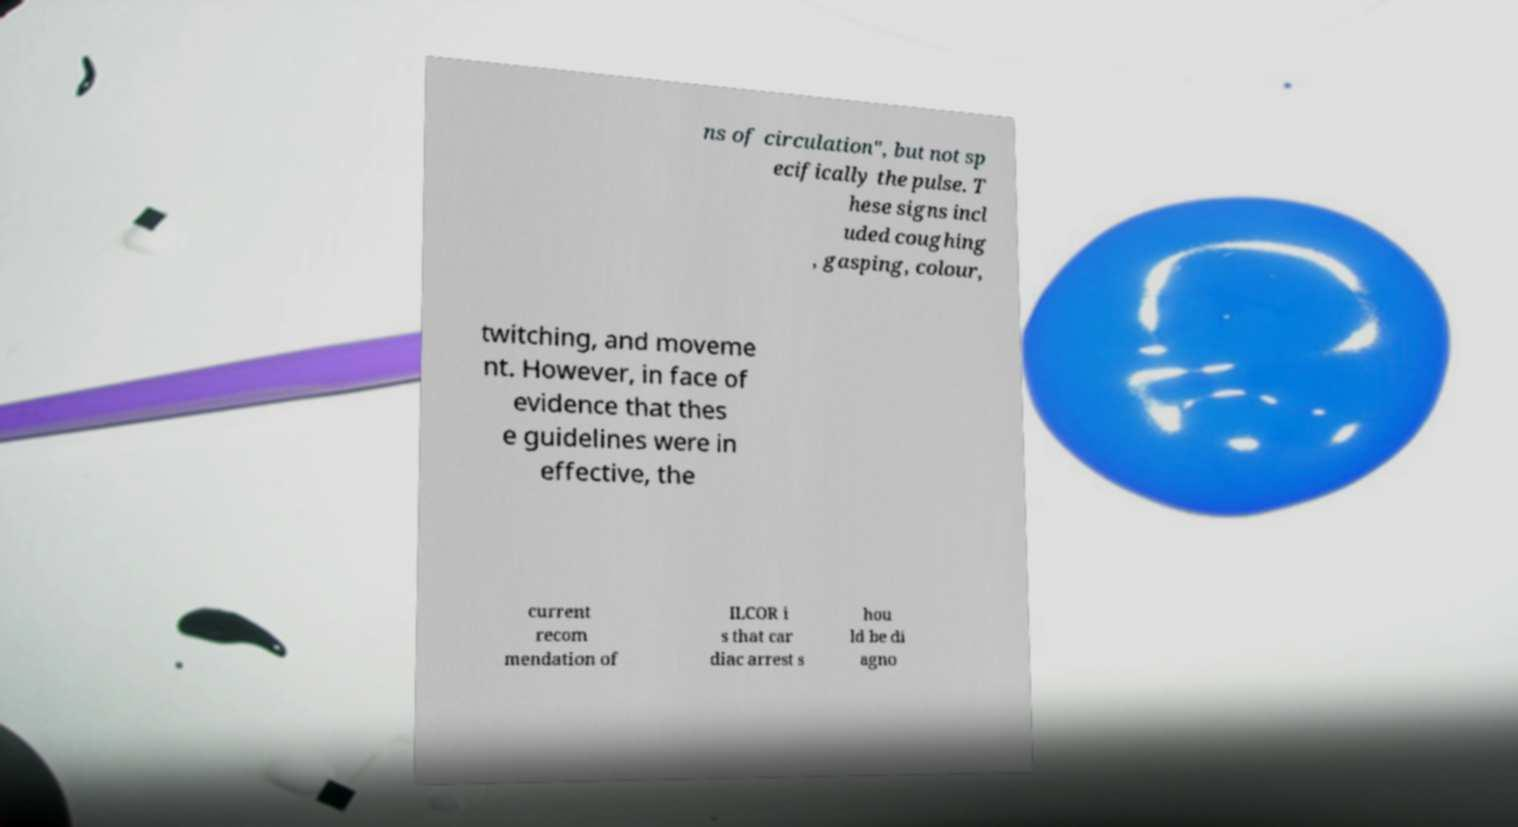Can you accurately transcribe the text from the provided image for me? ns of circulation", but not sp ecifically the pulse. T hese signs incl uded coughing , gasping, colour, twitching, and moveme nt. However, in face of evidence that thes e guidelines were in effective, the current recom mendation of ILCOR i s that car diac arrest s hou ld be di agno 